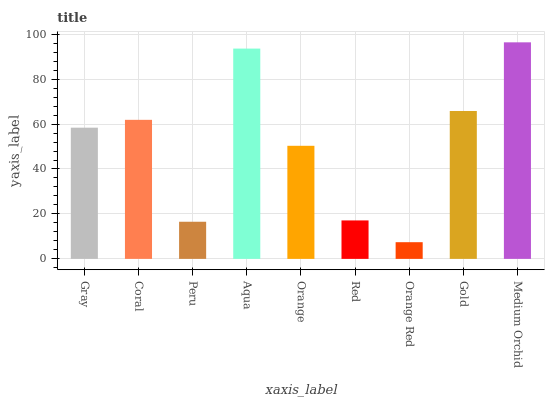Is Orange Red the minimum?
Answer yes or no. Yes. Is Medium Orchid the maximum?
Answer yes or no. Yes. Is Coral the minimum?
Answer yes or no. No. Is Coral the maximum?
Answer yes or no. No. Is Coral greater than Gray?
Answer yes or no. Yes. Is Gray less than Coral?
Answer yes or no. Yes. Is Gray greater than Coral?
Answer yes or no. No. Is Coral less than Gray?
Answer yes or no. No. Is Gray the high median?
Answer yes or no. Yes. Is Gray the low median?
Answer yes or no. Yes. Is Red the high median?
Answer yes or no. No. Is Aqua the low median?
Answer yes or no. No. 